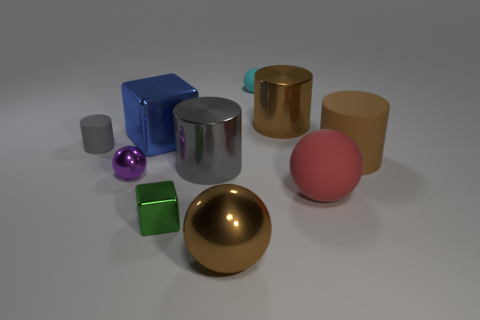There is a big sphere that is made of the same material as the small green thing; what color is it?
Provide a short and direct response. Brown. Is the shape of the tiny gray thing the same as the big brown metallic thing behind the green thing?
Make the answer very short. Yes. What is the material of the gray object that is the same size as the green shiny cube?
Your response must be concise. Rubber. Are there any big shiny blocks that have the same color as the large rubber cylinder?
Your answer should be compact. No. What shape is the big object that is on the left side of the brown shiny cylinder and in front of the big gray shiny cylinder?
Offer a terse response. Sphere. How many blue objects are made of the same material as the large red thing?
Provide a succinct answer. 0. Is the number of small cylinders that are behind the small rubber ball less than the number of rubber cylinders that are to the left of the green shiny object?
Your answer should be compact. Yes. The thing left of the metallic ball that is on the left side of the large metal ball that is on the left side of the red matte sphere is made of what material?
Your answer should be very brief. Rubber. What size is the shiny object that is behind the large red matte object and in front of the large gray object?
Keep it short and to the point. Small. How many cylinders are red matte things or tiny cyan rubber things?
Your answer should be very brief. 0. 